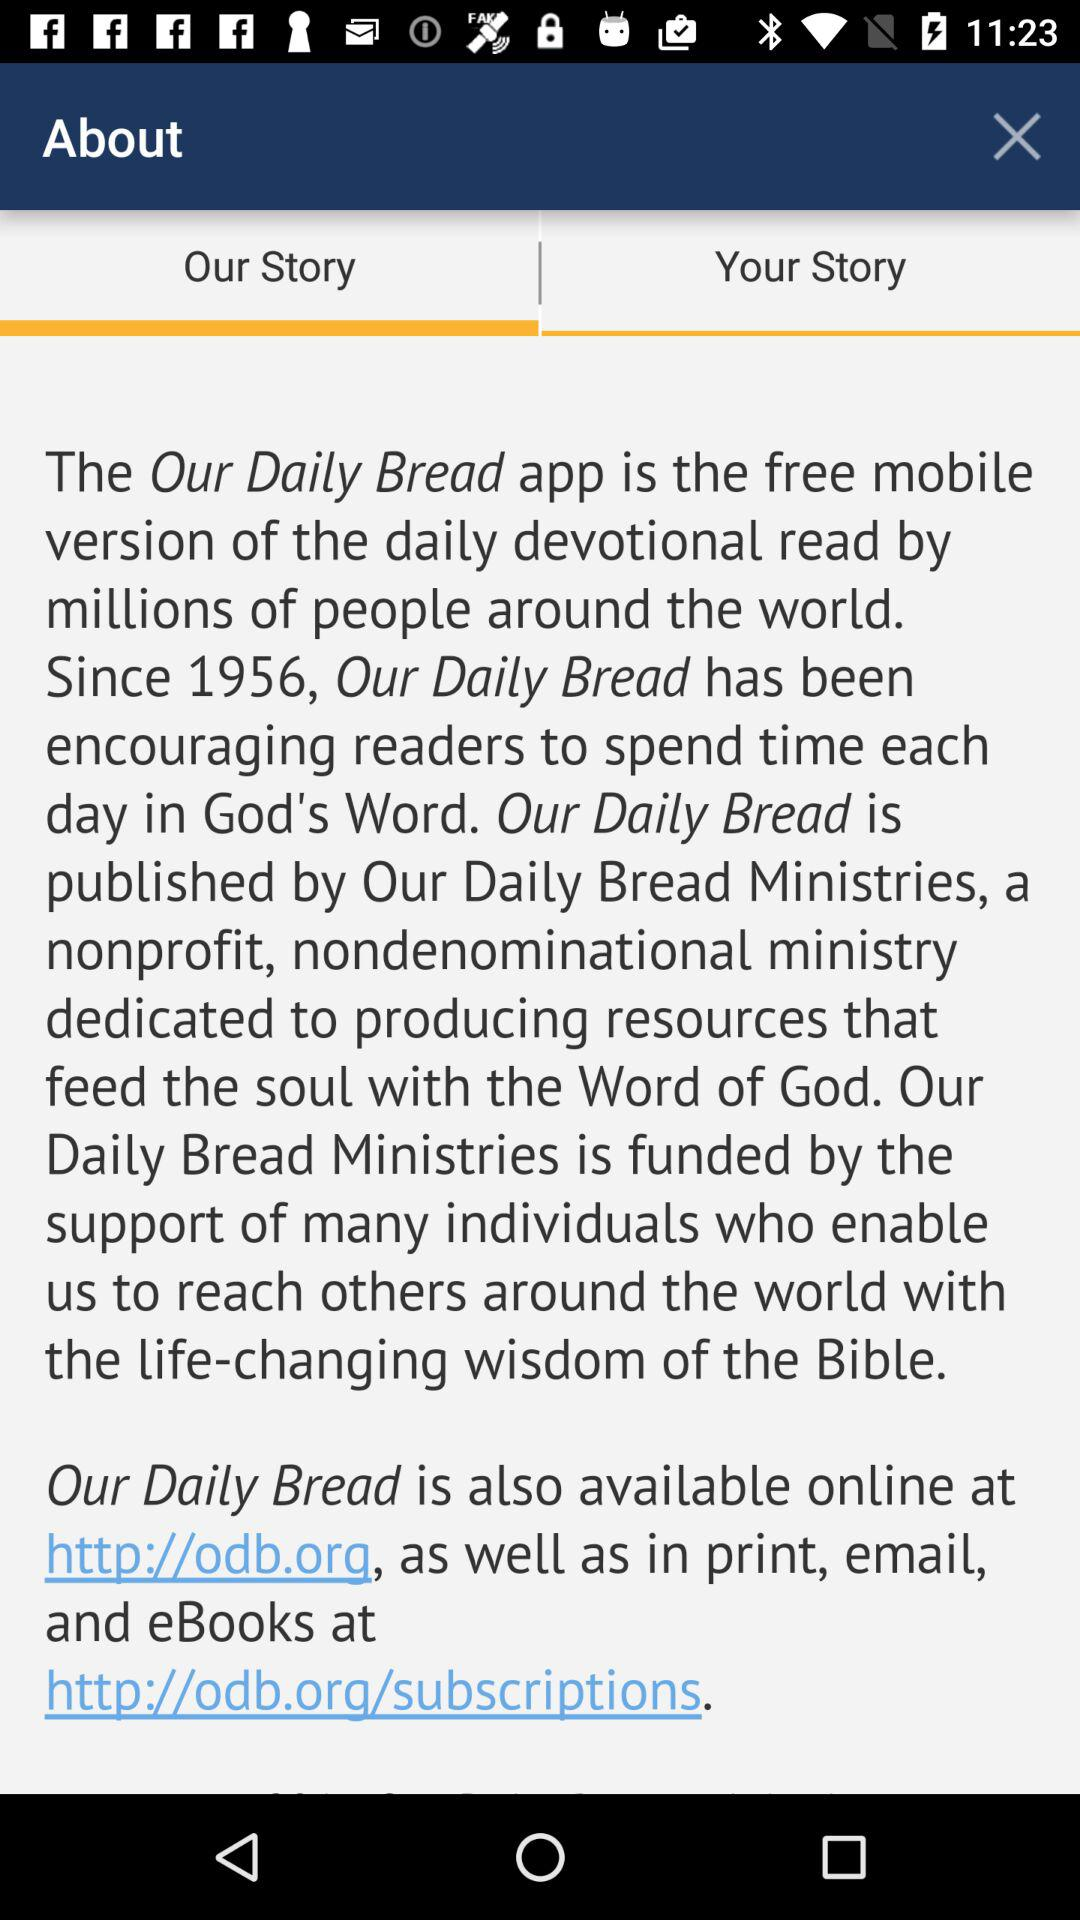How many links are there on this screen?
Answer the question using a single word or phrase. 2 